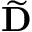Convert formula to latex. <formula><loc_0><loc_0><loc_500><loc_500>\widetilde { D }</formula> 